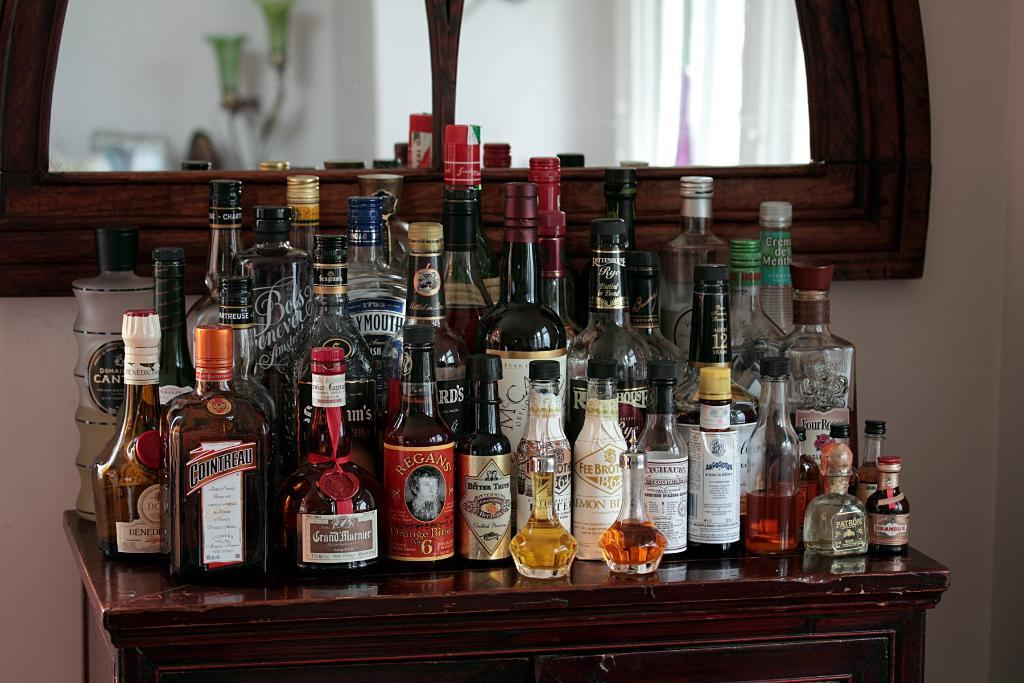<image>
Summarize the visual content of the image. the word Grand is on a bottle of alcohol 